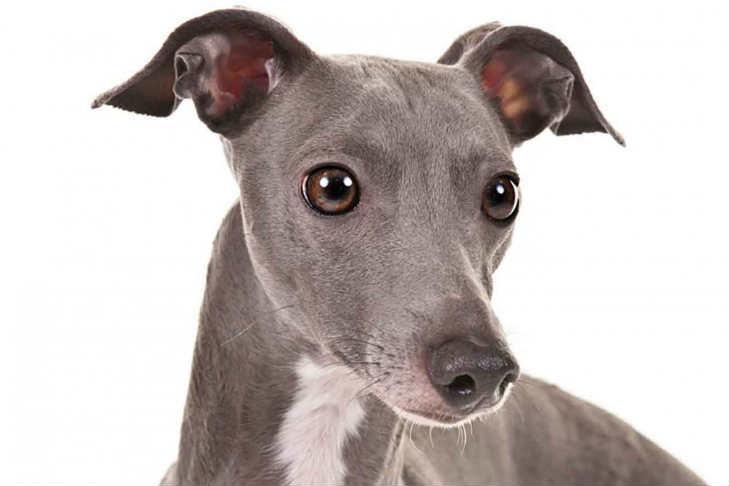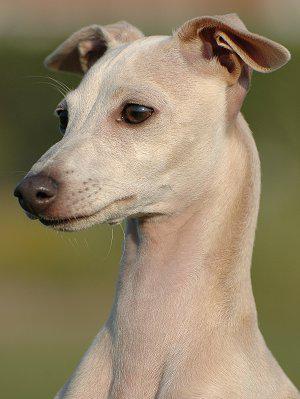The first image is the image on the left, the second image is the image on the right. Evaluate the accuracy of this statement regarding the images: "There is a plant behind at least one of the dogs.". Is it true? Answer yes or no. No. The first image is the image on the left, the second image is the image on the right. Assess this claim about the two images: "the dog in the image on the right has its tail tucked between its legs". Correct or not? Answer yes or no. No. 